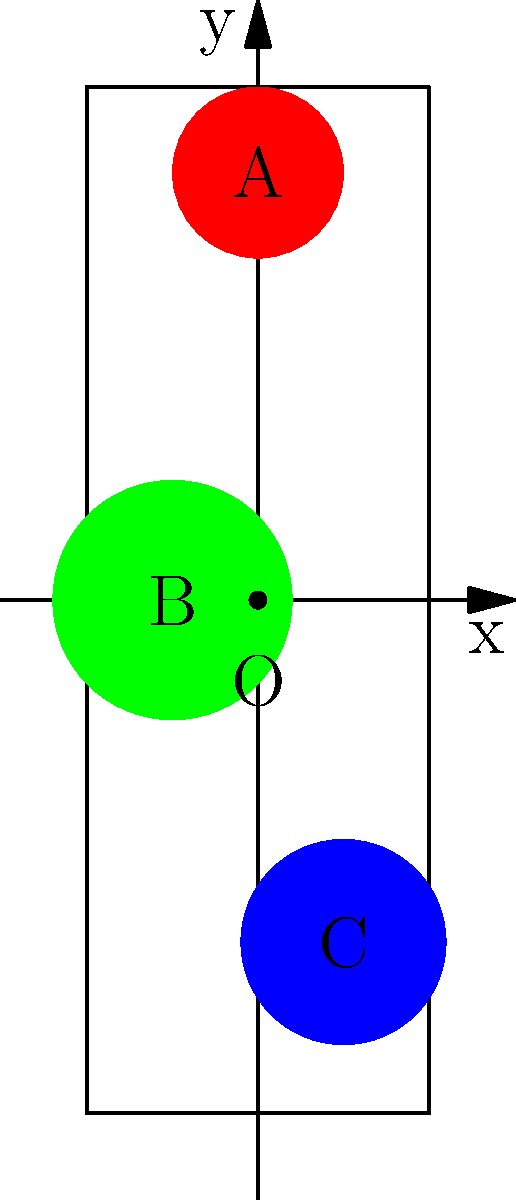The diagram shows Rangana Herath's three most prolific wicket-taking zones on a cricket pitch coordinate system. Zone A is centered at (0, 2.5) with a radius of 0.5, Zone B at (-0.5, 0) with a radius of 0.7, and Zone C at (0.5, -2) with a radius of 0.6. If a batsman's shot lands at the point (0.3, -1.5), in which zone does it fall? To determine which zone the shot falls into, we need to calculate the distance between the given point (0.3, -1.5) and the center of each zone. If this distance is less than or equal to the radius of the zone, the point falls within that zone.

1. For Zone A:
   Center: (0, 2.5), Radius: 0.5
   Distance = $\sqrt{(0.3-0)^2 + (-1.5-2.5)^2} = \sqrt{0.09 + 16} = 4.01$
   4.01 > 0.5, so the point is not in Zone A.

2. For Zone B:
   Center: (-0.5, 0), Radius: 0.7
   Distance = $\sqrt{(0.3-(-0.5))^2 + (-1.5-0)^2} = \sqrt{0.64 + 2.25} = 1.71$
   1.71 > 0.7, so the point is not in Zone B.

3. For Zone C:
   Center: (0.5, -2), Radius: 0.6
   Distance = $\sqrt{(0.3-0.5)^2 + (-1.5-(-2))^2} = \sqrt{0.04 + 0.25} = 0.51$
   0.51 < 0.6, so the point is in Zone C.

Therefore, the batsman's shot lands in Zone C.
Answer: Zone C 